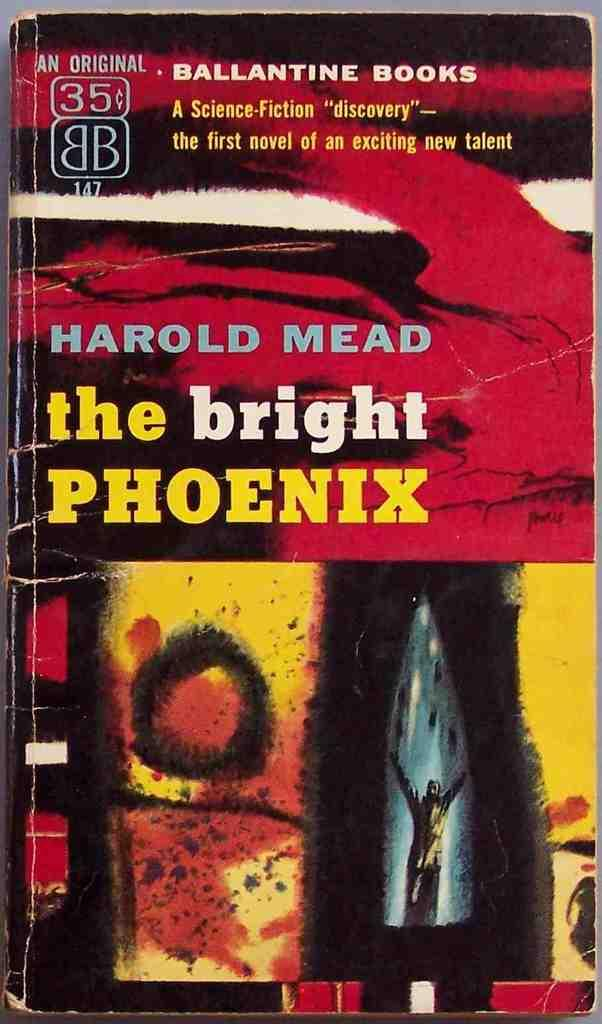<image>
Describe the image concisely. A book cover that is titled the Bright Phoenix by Harold Mead 